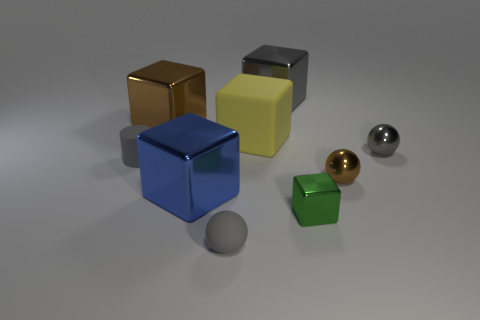There is a rubber sphere that is the same color as the small rubber cylinder; what is its size?
Ensure brevity in your answer.  Small. There is a green thing; what shape is it?
Provide a succinct answer. Cube. The tiny matte object on the left side of the tiny gray sphere left of the gray ball that is behind the tiny green cube is what shape?
Ensure brevity in your answer.  Cylinder. How many other things are the same shape as the yellow thing?
Offer a very short reply. 4. There is a tiny gray ball on the right side of the tiny brown metal object on the right side of the blue object; what is its material?
Give a very brief answer. Metal. Does the tiny cube have the same material as the small object that is behind the matte cylinder?
Your answer should be compact. Yes. The large object that is right of the tiny gray matte ball and in front of the large gray metal block is made of what material?
Keep it short and to the point. Rubber. What is the color of the rubber thing to the right of the sphere that is in front of the small brown shiny thing?
Provide a succinct answer. Yellow. What material is the big brown block that is behind the blue shiny thing?
Offer a very short reply. Metal. Are there fewer blue things than rubber objects?
Ensure brevity in your answer.  Yes. 